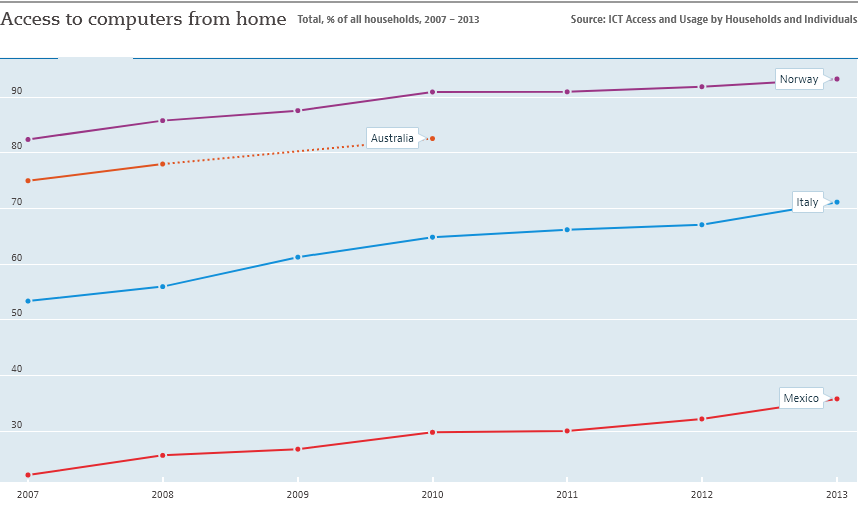Can you describe the trend for Australia's access to computers from home as shown in this graph? Certainly! The graph indicates that Australia experienced a steady increase in the percentage of households with access to computers from home, starting at around 70% in 2007 and approaching 90% by 2013. The trend shows consistent growth year on year. 